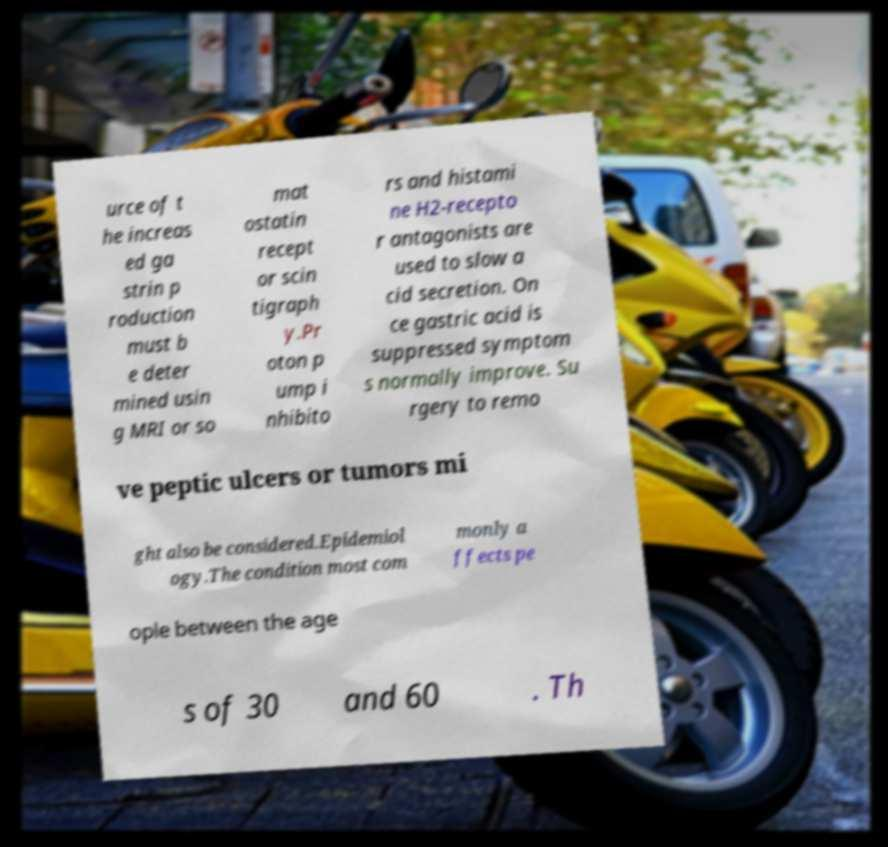Can you accurately transcribe the text from the provided image for me? urce of t he increas ed ga strin p roduction must b e deter mined usin g MRI or so mat ostatin recept or scin tigraph y.Pr oton p ump i nhibito rs and histami ne H2-recepto r antagonists are used to slow a cid secretion. On ce gastric acid is suppressed symptom s normally improve. Su rgery to remo ve peptic ulcers or tumors mi ght also be considered.Epidemiol ogy.The condition most com monly a ffects pe ople between the age s of 30 and 60 . Th 